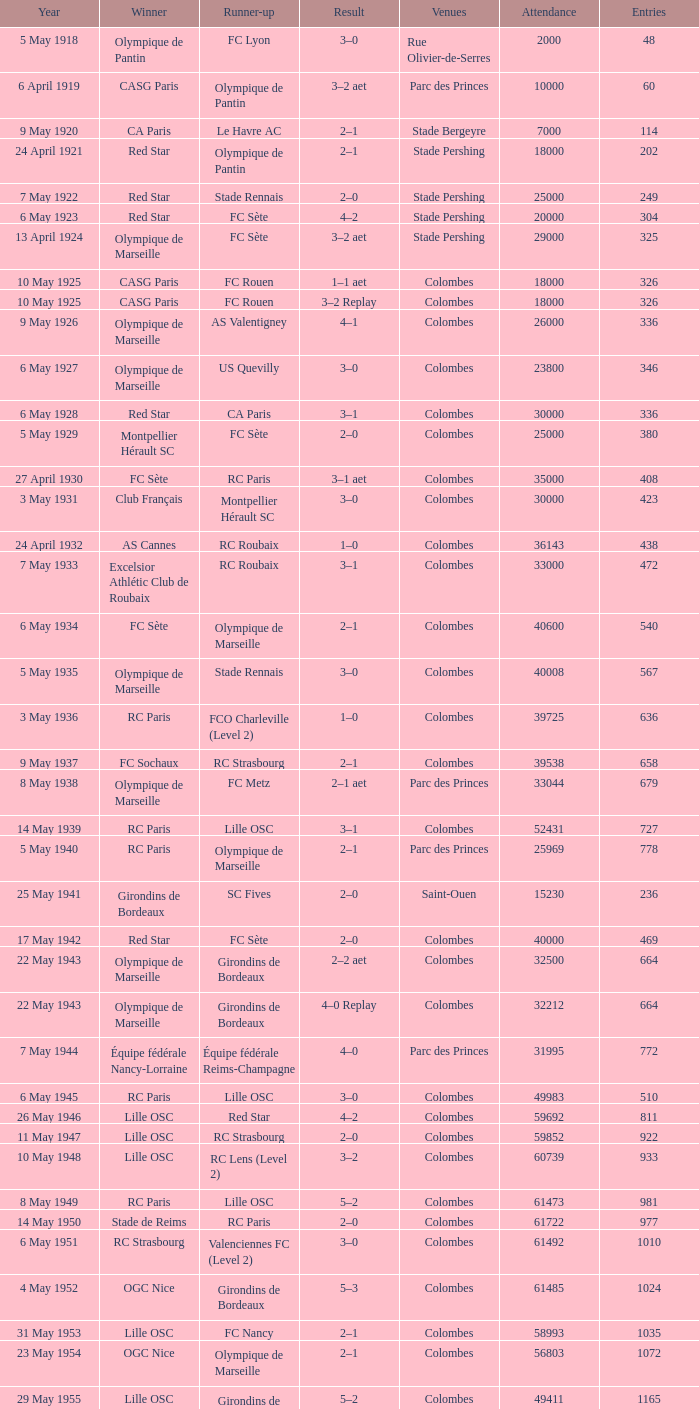What is the lowest number of recorded participants against paris saint-germain? 6394.0. Would you mind parsing the complete table? {'header': ['Year', 'Winner', 'Runner-up', 'Result', 'Venues', 'Attendance', 'Entries'], 'rows': [['5 May 1918', 'Olympique de Pantin', 'FC Lyon', '3–0', 'Rue Olivier-de-Serres', '2000', '48'], ['6 April 1919', 'CASG Paris', 'Olympique de Pantin', '3–2 aet', 'Parc des Princes', '10000', '60'], ['9 May 1920', 'CA Paris', 'Le Havre AC', '2–1', 'Stade Bergeyre', '7000', '114'], ['24 April 1921', 'Red Star', 'Olympique de Pantin', '2–1', 'Stade Pershing', '18000', '202'], ['7 May 1922', 'Red Star', 'Stade Rennais', '2–0', 'Stade Pershing', '25000', '249'], ['6 May 1923', 'Red Star', 'FC Sète', '4–2', 'Stade Pershing', '20000', '304'], ['13 April 1924', 'Olympique de Marseille', 'FC Sète', '3–2 aet', 'Stade Pershing', '29000', '325'], ['10 May 1925', 'CASG Paris', 'FC Rouen', '1–1 aet', 'Colombes', '18000', '326'], ['10 May 1925', 'CASG Paris', 'FC Rouen', '3–2 Replay', 'Colombes', '18000', '326'], ['9 May 1926', 'Olympique de Marseille', 'AS Valentigney', '4–1', 'Colombes', '26000', '336'], ['6 May 1927', 'Olympique de Marseille', 'US Quevilly', '3–0', 'Colombes', '23800', '346'], ['6 May 1928', 'Red Star', 'CA Paris', '3–1', 'Colombes', '30000', '336'], ['5 May 1929', 'Montpellier Hérault SC', 'FC Sète', '2–0', 'Colombes', '25000', '380'], ['27 April 1930', 'FC Sète', 'RC Paris', '3–1 aet', 'Colombes', '35000', '408'], ['3 May 1931', 'Club Français', 'Montpellier Hérault SC', '3–0', 'Colombes', '30000', '423'], ['24 April 1932', 'AS Cannes', 'RC Roubaix', '1–0', 'Colombes', '36143', '438'], ['7 May 1933', 'Excelsior Athlétic Club de Roubaix', 'RC Roubaix', '3–1', 'Colombes', '33000', '472'], ['6 May 1934', 'FC Sète', 'Olympique de Marseille', '2–1', 'Colombes', '40600', '540'], ['5 May 1935', 'Olympique de Marseille', 'Stade Rennais', '3–0', 'Colombes', '40008', '567'], ['3 May 1936', 'RC Paris', 'FCO Charleville (Level 2)', '1–0', 'Colombes', '39725', '636'], ['9 May 1937', 'FC Sochaux', 'RC Strasbourg', '2–1', 'Colombes', '39538', '658'], ['8 May 1938', 'Olympique de Marseille', 'FC Metz', '2–1 aet', 'Parc des Princes', '33044', '679'], ['14 May 1939', 'RC Paris', 'Lille OSC', '3–1', 'Colombes', '52431', '727'], ['5 May 1940', 'RC Paris', 'Olympique de Marseille', '2–1', 'Parc des Princes', '25969', '778'], ['25 May 1941', 'Girondins de Bordeaux', 'SC Fives', '2–0', 'Saint-Ouen', '15230', '236'], ['17 May 1942', 'Red Star', 'FC Sète', '2–0', 'Colombes', '40000', '469'], ['22 May 1943', 'Olympique de Marseille', 'Girondins de Bordeaux', '2–2 aet', 'Colombes', '32500', '664'], ['22 May 1943', 'Olympique de Marseille', 'Girondins de Bordeaux', '4–0 Replay', 'Colombes', '32212', '664'], ['7 May 1944', 'Équipe fédérale Nancy-Lorraine', 'Équipe fédérale Reims-Champagne', '4–0', 'Parc des Princes', '31995', '772'], ['6 May 1945', 'RC Paris', 'Lille OSC', '3–0', 'Colombes', '49983', '510'], ['26 May 1946', 'Lille OSC', 'Red Star', '4–2', 'Colombes', '59692', '811'], ['11 May 1947', 'Lille OSC', 'RC Strasbourg', '2–0', 'Colombes', '59852', '922'], ['10 May 1948', 'Lille OSC', 'RC Lens (Level 2)', '3–2', 'Colombes', '60739', '933'], ['8 May 1949', 'RC Paris', 'Lille OSC', '5–2', 'Colombes', '61473', '981'], ['14 May 1950', 'Stade de Reims', 'RC Paris', '2–0', 'Colombes', '61722', '977'], ['6 May 1951', 'RC Strasbourg', 'Valenciennes FC (Level 2)', '3–0', 'Colombes', '61492', '1010'], ['4 May 1952', 'OGC Nice', 'Girondins de Bordeaux', '5–3', 'Colombes', '61485', '1024'], ['31 May 1953', 'Lille OSC', 'FC Nancy', '2–1', 'Colombes', '58993', '1035'], ['23 May 1954', 'OGC Nice', 'Olympique de Marseille', '2–1', 'Colombes', '56803', '1072'], ['29 May 1955', 'Lille OSC', 'Girondins de Bordeaux', '5–2', 'Colombes', '49411', '1165'], ['27 May 1956', 'CS Sedan', 'ES Troyes AC', '3–1', 'Colombes', '47258', '1203'], ['26 May 1957', 'Toulouse FC', 'SCO Angers', '6–3', 'Colombes', '43125', '1149'], ['18 May 1958', 'Stade de Reims', 'Nîmes Olympique', '3–1', 'Colombes', '56523', '1163'], ['18 May 1959', 'Le Havre AC (Level 2)', 'FC Sochaux', '2–2 aet', 'Colombes', '36655', '1159'], ['18 May 1959', 'Le Havre AC (Level 2)', 'FC Sochaux', '3–0 Replay', 'Colombes', '36655', '1159'], ['15 May 1960', 'AS Monaco', 'AS Saint-Étienne', '4–2 aet', 'Colombes', '38298', '1187'], ['7 May 1961', 'CS Sedan', 'Nîmes Olympique', '3–1', 'Colombes', '39070', '1193'], ['13 May 1962', 'AS Saint-Étienne', 'FC Nancy', '1–0', 'Colombes', '30654', '1226'], ['23 May 1963', 'AS Monaco', 'Olympique Lyonnais', '0–0 aet', 'Colombes', '32923', '1209'], ['23 May 1963', 'AS Monaco', 'Olympique Lyonnais', '2–0 Replay', 'Colombes', '24910', '1209'], ['10 May 1964', 'Olympique Lyonnais', 'Girondins de Bordeaux', '2–0', 'Colombes', '32777', '1203'], ['26 May 1965', 'Stade Rennais', 'CS Sedan', '2–2 aet', 'Parc des Princes', '36789', '1183'], ['26 May 1965', 'Stade Rennais', 'CS Sedan', '3–1 Replay', 'Parc des Princes', '26792', '1183'], ['22 May 1966', 'RC Strasbourg', 'FC Nantes', '1–0', 'Parc des Princes', '36285', '1190'], ['21 May 1967', 'Olympique Lyonnais', 'FC Sochaux', '3–1', 'Parc des Princes', '32523', '1378'], ['12 May 1968', 'AS Saint-Étienne', 'Girondins de Bordeaux', '2–1', 'Colombes', '33959', '1378'], ['18 May 1969', 'Olympique de Marseille', 'Girondins de Bordeaux', '2–0', 'Colombes', '39460', '1377'], ['31 May 1970', 'AS Saint-Étienne', 'FC Nantes', '5–0', 'Colombes', '32894', '1375'], ['20 June 1971', 'Stade Rennais', 'Olympique Lyonnais', '1–0', 'Colombes', '46801', '1383'], ['4 June 1972', 'Olympique de Marseille', 'SC Bastia', '2–1', 'Parc des Princes', '44069', '1596'], ['17 June 1973', 'Olympique Lyonnais', 'FC Nantes', '2–1', 'Parc des Princes', '45734', '1596'], ['8 June 1974', 'AS Saint-Étienne', 'AS Monaco', '2–1', 'Parc des Princes', '45813', '1720'], ['14 June 1975', 'AS Saint-Étienne', 'RC Lens', '2–0', 'Parc des Princes', '44725', '1940'], ['12 June 1976', 'Olympique de Marseille', 'Olympique Lyonnais', '2–0', 'Parc des Princes', '45661', '1977'], ['18 June 1977', 'AS Saint-Étienne', 'Stade de Reims', '2–1', 'Parc des Princes', '45454', '2084'], ['13 May 1978', 'AS Nancy', 'OGC Nice', '1–0', 'Parc des Princes', '45998', '2544'], ['16 June 1979', 'FC Nantes', 'AJ Auxerre (Level 2)', '4–1 aet', 'Parc des Princes', '46070', '2473'], ['7 June 1980', 'AS Monaco', 'US Orléans (Level 2)', '3–1', 'Parc des Princes', '46136', '2473'], ['13 June 1981', 'SC Bastia', 'AS Saint-Étienne', '2–1', 'Parc des Princes', '46155', '2924'], ['15 May 1982', 'Paris SG', 'AS Saint-Étienne', '2–2 aet 6–5 pen', 'Parc des Princes', '46160', '3179'], ['11 June 1983', 'Paris SG', 'FC Nantes', '3–2', 'Parc des Princes', '46203', '3280'], ['11 May 1984', 'FC Metz', 'AS Monaco', '2–0 aet', 'Parc des Princes', '45384', '3705'], ['8 June 1985', 'AS Monaco', 'Paris SG', '1–0', 'Parc des Princes', '45711', '3983'], ['30 April 1986', 'Girondins de Bordeaux', 'Olympique de Marseille', '2–1 aet', 'Parc des Princes', '45429', '4117'], ['10 June 1987', 'Girondins de Bordeaux', 'Olympique de Marseille', '2–0', 'Parc des Princes', '45145', '4964'], ['11 June 1988', 'FC Metz', 'FC Sochaux', '1–1 aet 5–4 pen', 'Parc des Princes', '44531', '5293'], ['10 June 1989', 'Olympique de Marseille', 'AS Monaco', '4–3', 'Parc des Princes', '44448', '5293'], ['2 June 1990', 'Montpellier Hérault SC', 'RC Paris', '2–1 aet', 'Parc des Princes', '44067', '5972'], ['8 June 1991', 'AS Monaco', 'Olympique de Marseille', '1–0', 'Parc des Princes', '44123', '6065'], ['12 June 1993', 'Paris SG', 'FC Nantes', '3–0', 'Parc des Princes', '48789', '6523'], ['14 May 1994', 'AJ Auxerre', 'Montpellier HSC', '3–0', 'Parc des Princes', '45189', '6261'], ['13 May 1995', 'Paris SG', 'RC Strasbourg', '1–0', 'Parc des Princes', '46698', '5975'], ['4 May 1996', 'AJ Auxerre', 'Nîmes Olympique (Level 3)', '2–1', 'Parc des Princes', '44921', '5847'], ['10 May 1997', 'OGC Nice', 'En Avant de Guingamp', '1–1 aet 4–3 pen', 'Parc des Princes', '44131', '5986'], ['2 May 1998', 'Paris SG', 'RC Lens', '2–1', 'Stade de France', '78265', '6106'], ['15 May 1999', 'FC Nantes', 'CS Sedan (Level 2)', '1–0', 'Stade de France', '78586', '5957'], ['7 May 2000', 'FC Nantes', 'Calais RUFC (Level 4)', '2–1', 'Stade de France', '78717', '6096'], ['26 May 2001', 'RC Strasbourg', 'Amiens SC (Level 2)', '0–0 aet 5–4 pen', 'Stade de France', '78641', '6375'], ['11 May 2002', 'FC Lorient', 'SC Bastia', '1–0', 'Stade de France', '66215', '5848'], ['31 May 2003', 'AJ Auxerre', 'Paris SG', '2–1', 'Stade de France', '78316', '5850'], ['29 May 2004', 'Paris SG', 'LB Châteauroux (Level 2)', '1–0', 'Stade de France', '78357', '6057'], ['4 June 2005', 'AJ Auxerre', 'CS Sedan', '2–1', 'Stade de France', '78721', '6263'], ['29 April 2006', 'Paris Saint-Germain', 'Olympique de Marseille', '2–1', 'Stade de France', '79797', '6394'], ['12 May 2007', 'FC Sochaux', 'Olympique de Marseille', '2–2 aet 5–4 pen', 'Stade de France', '79850', '6577'], ['24 May 2008', 'Olympique Lyonnais', 'Paris Saint-Germain', '1–0', 'Stade de France', '79204', '6734'], ['9 May 2009', 'EA Guingamp (Level 2)', 'Stade Rennais', '2–1', 'Stade de France', '80056', '7246'], ['1 May 2010', 'Paris Saint-Germain', 'AS Monaco', '1–0 aet', 'Stade de France', '74000', '7317'], ['14 May 2011', 'Lille', 'Paris Saint-Germain', '1–0', 'Stade de France', '79000', '7449'], ['28 April 2012', 'Olympique Lyonnais', 'US Quevilly (Level 3)', '1–0', 'Stade de France', '76293', '7422']]} 